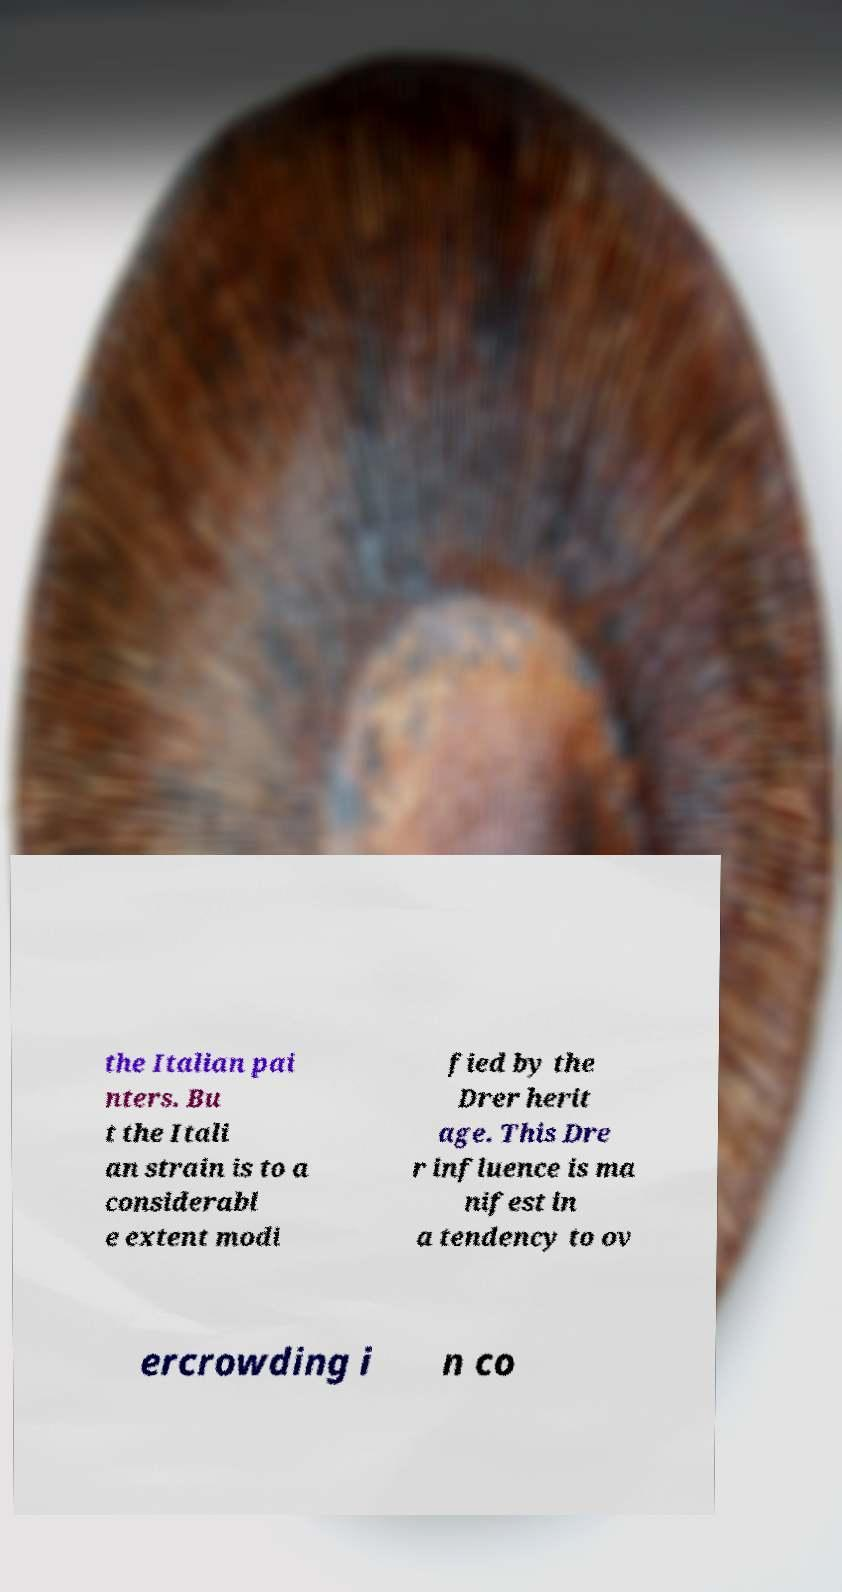I need the written content from this picture converted into text. Can you do that? the Italian pai nters. Bu t the Itali an strain is to a considerabl e extent modi fied by the Drer herit age. This Dre r influence is ma nifest in a tendency to ov ercrowding i n co 